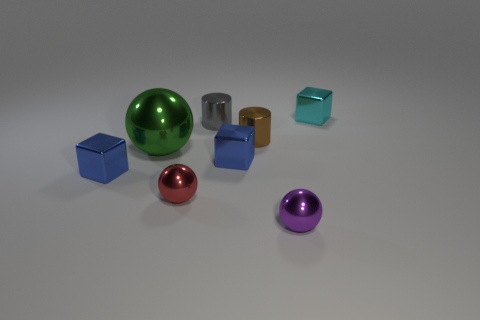Subtract all small balls. How many balls are left? 1 Subtract all brown cylinders. How many cylinders are left? 1 Subtract all balls. How many objects are left? 5 Subtract 1 cylinders. How many cylinders are left? 1 Add 1 tiny cyan spheres. How many objects exist? 9 Subtract all yellow cylinders. Subtract all red cubes. How many cylinders are left? 2 Subtract all cyan spheres. How many brown cylinders are left? 1 Subtract all big purple rubber cylinders. Subtract all small red things. How many objects are left? 7 Add 8 cyan cubes. How many cyan cubes are left? 9 Add 4 tiny blue objects. How many tiny blue objects exist? 6 